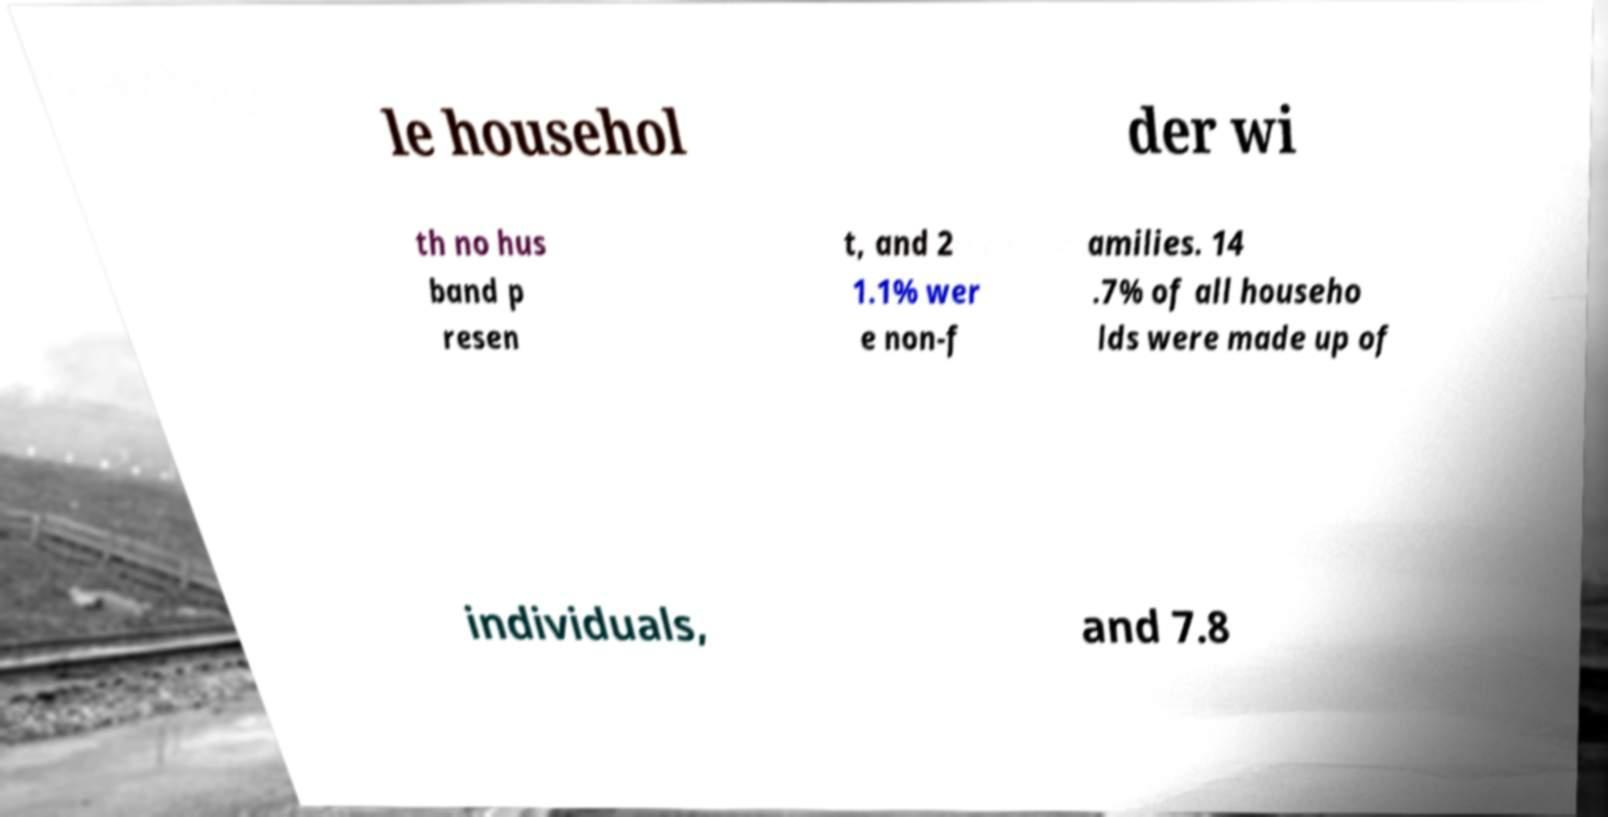Could you extract and type out the text from this image? le househol der wi th no hus band p resen t, and 2 1.1% wer e non-f amilies. 14 .7% of all househo lds were made up of individuals, and 7.8 